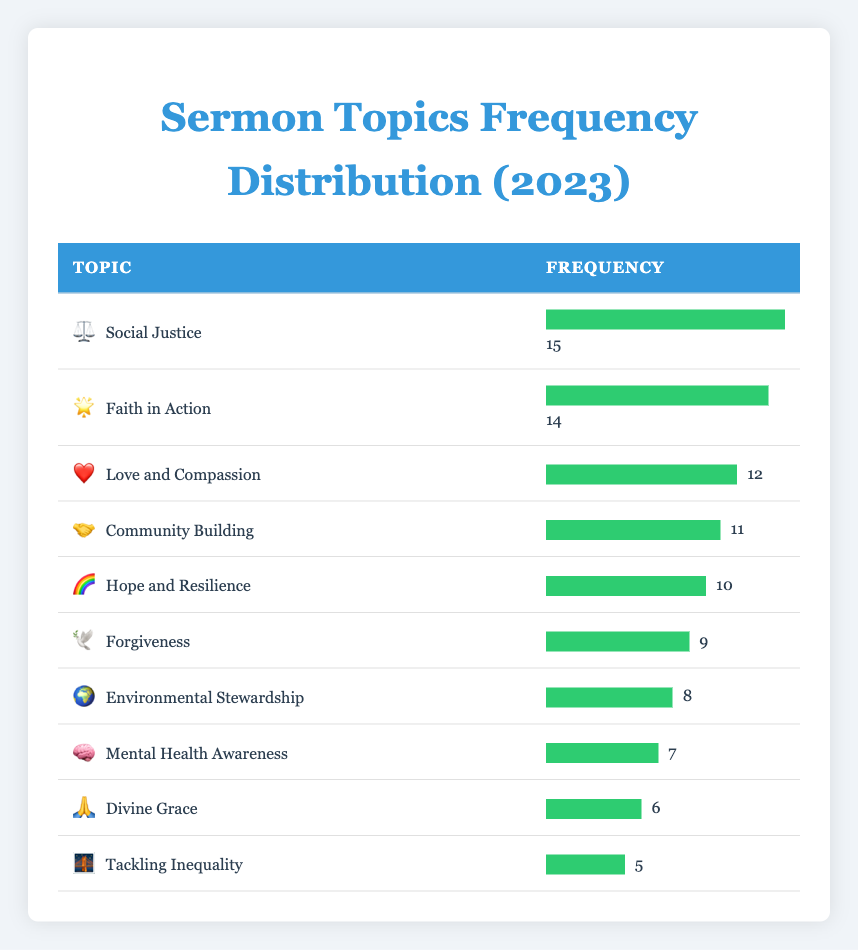What is the most frequently addressed sermon topic in 2023? By looking at the frequency column in the table, we can identify the highest frequency value. The topic with the highest frequency is Social Justice, which has a frequency of 15.
Answer: Social Justice How many sermons were focused on Love and Compassion? The table directly shows that the frequency for the topic Love and Compassion is 12.
Answer: 12 Which topic was addressed the least in the sermons? Examining the frequency of each topic, Tackling Inequality has the lowest frequency at 5.
Answer: Tackling Inequality What is the total frequency of the topics: Environmental Stewardship, Forgiveness, and Mental Health Awareness? We find the frequencies for these topics: Environmental Stewardship = 8, Forgiveness = 9, and Mental Health Awareness = 7. Adding these gives 8 + 9 + 7 = 24.
Answer: 24 Are there more sermons on Faith in Action than on Hope and Resilience? The frequency for Faith in Action is 14 and for Hope and Resilience is 10. Since 14 is greater than 10, the statement is true.
Answer: Yes What is the average frequency of the sermon topics listed in the table? First, we sum the frequencies of all topics: 15 + 14 + 12 + 11 + 10 + 9 + 8 + 7 + 6 + 5 = 97. There are 10 topics, so we divide the total by the number of topics: 97 / 10 = 9.7.
Answer: 9.7 How many more sermons were there on Community Building compared to Mental Health Awareness? The frequency for Community Building is 11, and for Mental Health Awareness, it is 7. The difference is 11 - 7 = 4.
Answer: 4 Is the frequency of Divine Grace greater than or equal to the frequency of Love and Compassion? The frequency for Divine Grace is 6, which is less than 12 (the frequency for Love and Compassion). Therefore, the statement is false.
Answer: No What percentage of the total sermon topics focused on Social Justice? First, we find the total frequency, which is 97. The frequency for Social Justice is 15. To find the percentage, we divide 15 by 97 and multiply by 100: (15/97) * 100 ≈ 15.46%.
Answer: Approximately 15.46% 